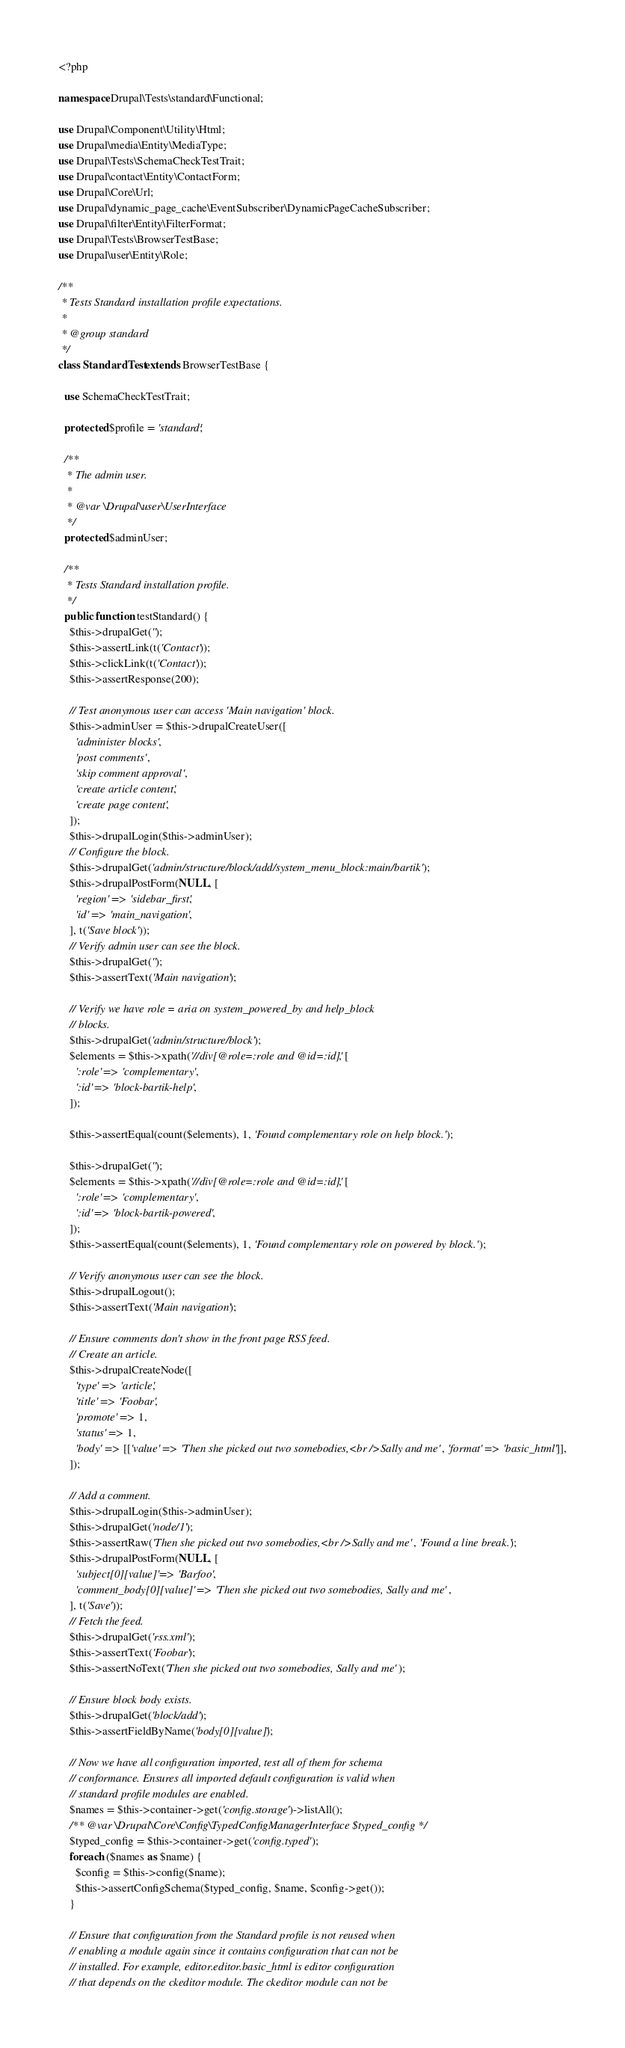<code> <loc_0><loc_0><loc_500><loc_500><_PHP_><?php

namespace Drupal\Tests\standard\Functional;

use Drupal\Component\Utility\Html;
use Drupal\media\Entity\MediaType;
use Drupal\Tests\SchemaCheckTestTrait;
use Drupal\contact\Entity\ContactForm;
use Drupal\Core\Url;
use Drupal\dynamic_page_cache\EventSubscriber\DynamicPageCacheSubscriber;
use Drupal\filter\Entity\FilterFormat;
use Drupal\Tests\BrowserTestBase;
use Drupal\user\Entity\Role;

/**
 * Tests Standard installation profile expectations.
 *
 * @group standard
 */
class StandardTest extends BrowserTestBase {

  use SchemaCheckTestTrait;

  protected $profile = 'standard';

  /**
   * The admin user.
   *
   * @var \Drupal\user\UserInterface
   */
  protected $adminUser;

  /**
   * Tests Standard installation profile.
   */
  public function testStandard() {
    $this->drupalGet('');
    $this->assertLink(t('Contact'));
    $this->clickLink(t('Contact'));
    $this->assertResponse(200);

    // Test anonymous user can access 'Main navigation' block.
    $this->adminUser = $this->drupalCreateUser([
      'administer blocks',
      'post comments',
      'skip comment approval',
      'create article content',
      'create page content',
    ]);
    $this->drupalLogin($this->adminUser);
    // Configure the block.
    $this->drupalGet('admin/structure/block/add/system_menu_block:main/bartik');
    $this->drupalPostForm(NULL, [
      'region' => 'sidebar_first',
      'id' => 'main_navigation',
    ], t('Save block'));
    // Verify admin user can see the block.
    $this->drupalGet('');
    $this->assertText('Main navigation');

    // Verify we have role = aria on system_powered_by and help_block
    // blocks.
    $this->drupalGet('admin/structure/block');
    $elements = $this->xpath('//div[@role=:role and @id=:id]', [
      ':role' => 'complementary',
      ':id' => 'block-bartik-help',
    ]);

    $this->assertEqual(count($elements), 1, 'Found complementary role on help block.');

    $this->drupalGet('');
    $elements = $this->xpath('//div[@role=:role and @id=:id]', [
      ':role' => 'complementary',
      ':id' => 'block-bartik-powered',
    ]);
    $this->assertEqual(count($elements), 1, 'Found complementary role on powered by block.');

    // Verify anonymous user can see the block.
    $this->drupalLogout();
    $this->assertText('Main navigation');

    // Ensure comments don't show in the front page RSS feed.
    // Create an article.
    $this->drupalCreateNode([
      'type' => 'article',
      'title' => 'Foobar',
      'promote' => 1,
      'status' => 1,
      'body' => [['value' => 'Then she picked out two somebodies,<br />Sally and me', 'format' => 'basic_html']],
    ]);

    // Add a comment.
    $this->drupalLogin($this->adminUser);
    $this->drupalGet('node/1');
    $this->assertRaw('Then she picked out two somebodies,<br />Sally and me', 'Found a line break.');
    $this->drupalPostForm(NULL, [
      'subject[0][value]' => 'Barfoo',
      'comment_body[0][value]' => 'Then she picked out two somebodies, Sally and me',
    ], t('Save'));
    // Fetch the feed.
    $this->drupalGet('rss.xml');
    $this->assertText('Foobar');
    $this->assertNoText('Then she picked out two somebodies, Sally and me');

    // Ensure block body exists.
    $this->drupalGet('block/add');
    $this->assertFieldByName('body[0][value]');

    // Now we have all configuration imported, test all of them for schema
    // conformance. Ensures all imported default configuration is valid when
    // standard profile modules are enabled.
    $names = $this->container->get('config.storage')->listAll();
    /** @var \Drupal\Core\Config\TypedConfigManagerInterface $typed_config */
    $typed_config = $this->container->get('config.typed');
    foreach ($names as $name) {
      $config = $this->config($name);
      $this->assertConfigSchema($typed_config, $name, $config->get());
    }

    // Ensure that configuration from the Standard profile is not reused when
    // enabling a module again since it contains configuration that can not be
    // installed. For example, editor.editor.basic_html is editor configuration
    // that depends on the ckeditor module. The ckeditor module can not be</code> 